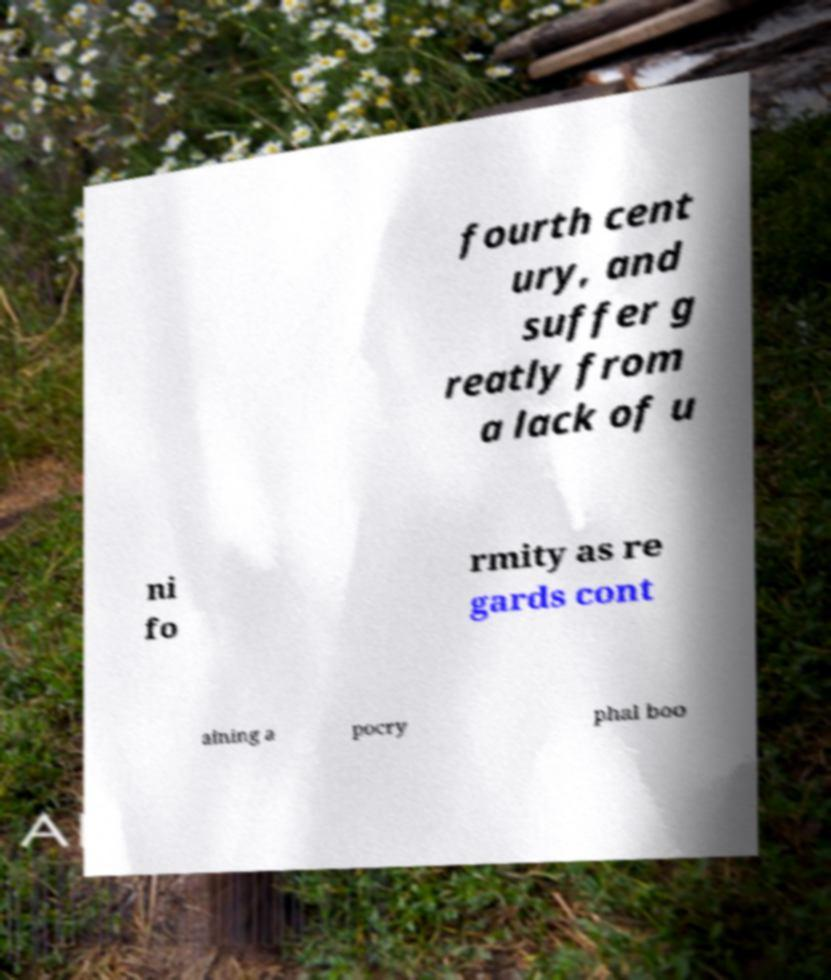Can you read and provide the text displayed in the image?This photo seems to have some interesting text. Can you extract and type it out for me? fourth cent ury, and suffer g reatly from a lack of u ni fo rmity as re gards cont aining a pocry phal boo 